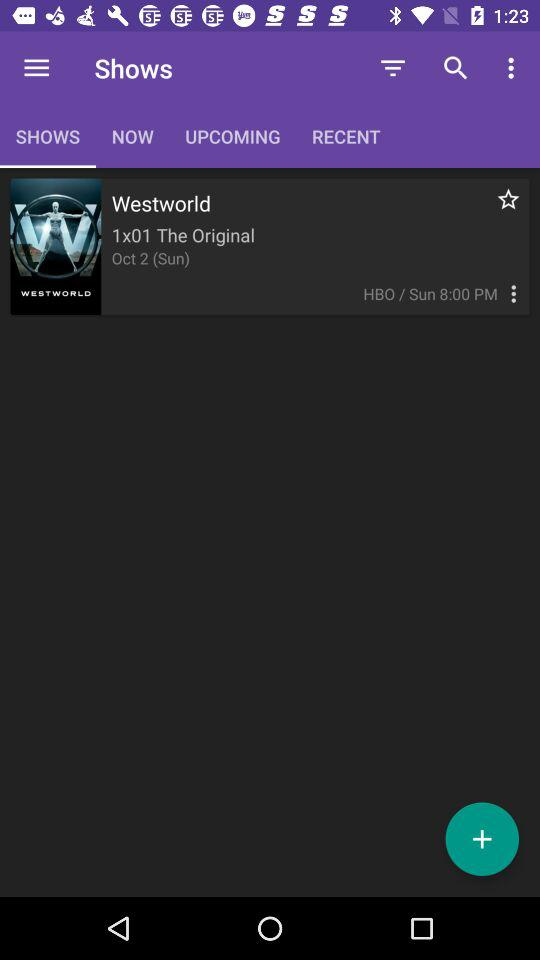What is the day on October 2? The day on October 2 is Sunday. 